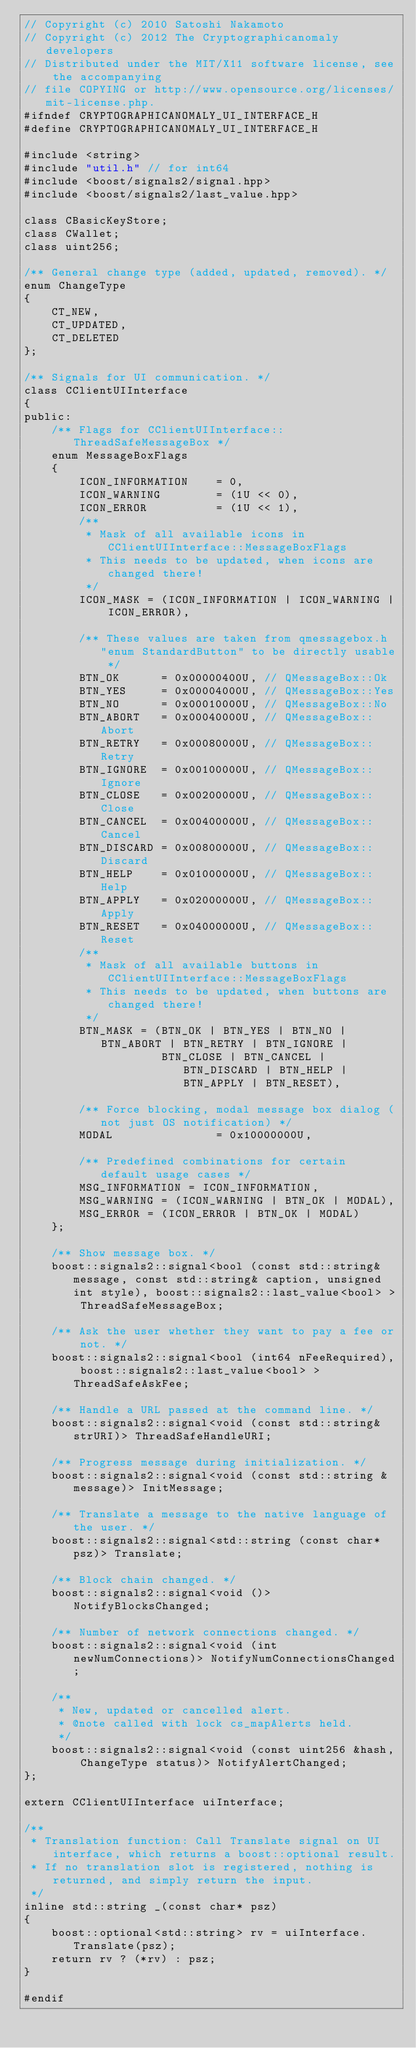Convert code to text. <code><loc_0><loc_0><loc_500><loc_500><_C_>// Copyright (c) 2010 Satoshi Nakamoto
// Copyright (c) 2012 The Cryptographicanomaly developers
// Distributed under the MIT/X11 software license, see the accompanying
// file COPYING or http://www.opensource.org/licenses/mit-license.php.
#ifndef CRYPTOGRAPHICANOMALY_UI_INTERFACE_H
#define CRYPTOGRAPHICANOMALY_UI_INTERFACE_H

#include <string>
#include "util.h" // for int64
#include <boost/signals2/signal.hpp>
#include <boost/signals2/last_value.hpp>

class CBasicKeyStore;
class CWallet;
class uint256;

/** General change type (added, updated, removed). */
enum ChangeType
{
    CT_NEW,
    CT_UPDATED,
    CT_DELETED
};

/** Signals for UI communication. */
class CClientUIInterface
{
public:
    /** Flags for CClientUIInterface::ThreadSafeMessageBox */
    enum MessageBoxFlags
    {
        ICON_INFORMATION    = 0,
        ICON_WARNING        = (1U << 0),
        ICON_ERROR          = (1U << 1),
        /**
         * Mask of all available icons in CClientUIInterface::MessageBoxFlags
         * This needs to be updated, when icons are changed there!
         */
        ICON_MASK = (ICON_INFORMATION | ICON_WARNING | ICON_ERROR),

        /** These values are taken from qmessagebox.h "enum StandardButton" to be directly usable */
        BTN_OK      = 0x00000400U, // QMessageBox::Ok
        BTN_YES     = 0x00004000U, // QMessageBox::Yes
        BTN_NO      = 0x00010000U, // QMessageBox::No
        BTN_ABORT   = 0x00040000U, // QMessageBox::Abort
        BTN_RETRY   = 0x00080000U, // QMessageBox::Retry
        BTN_IGNORE  = 0x00100000U, // QMessageBox::Ignore
        BTN_CLOSE   = 0x00200000U, // QMessageBox::Close
        BTN_CANCEL  = 0x00400000U, // QMessageBox::Cancel
        BTN_DISCARD = 0x00800000U, // QMessageBox::Discard
        BTN_HELP    = 0x01000000U, // QMessageBox::Help
        BTN_APPLY   = 0x02000000U, // QMessageBox::Apply
        BTN_RESET   = 0x04000000U, // QMessageBox::Reset
        /**
         * Mask of all available buttons in CClientUIInterface::MessageBoxFlags
         * This needs to be updated, when buttons are changed there!
         */
        BTN_MASK = (BTN_OK | BTN_YES | BTN_NO | BTN_ABORT | BTN_RETRY | BTN_IGNORE |
                    BTN_CLOSE | BTN_CANCEL | BTN_DISCARD | BTN_HELP | BTN_APPLY | BTN_RESET),

        /** Force blocking, modal message box dialog (not just OS notification) */
        MODAL               = 0x10000000U,

        /** Predefined combinations for certain default usage cases */
        MSG_INFORMATION = ICON_INFORMATION,
        MSG_WARNING = (ICON_WARNING | BTN_OK | MODAL),
        MSG_ERROR = (ICON_ERROR | BTN_OK | MODAL)
    };

    /** Show message box. */
    boost::signals2::signal<bool (const std::string& message, const std::string& caption, unsigned int style), boost::signals2::last_value<bool> > ThreadSafeMessageBox;

    /** Ask the user whether they want to pay a fee or not. */
    boost::signals2::signal<bool (int64 nFeeRequired), boost::signals2::last_value<bool> > ThreadSafeAskFee;

    /** Handle a URL passed at the command line. */
    boost::signals2::signal<void (const std::string& strURI)> ThreadSafeHandleURI;

    /** Progress message during initialization. */
    boost::signals2::signal<void (const std::string &message)> InitMessage;

    /** Translate a message to the native language of the user. */
    boost::signals2::signal<std::string (const char* psz)> Translate;

    /** Block chain changed. */
    boost::signals2::signal<void ()> NotifyBlocksChanged;

    /** Number of network connections changed. */
    boost::signals2::signal<void (int newNumConnections)> NotifyNumConnectionsChanged;

    /**
     * New, updated or cancelled alert.
     * @note called with lock cs_mapAlerts held.
     */
    boost::signals2::signal<void (const uint256 &hash, ChangeType status)> NotifyAlertChanged;
};

extern CClientUIInterface uiInterface;

/**
 * Translation function: Call Translate signal on UI interface, which returns a boost::optional result.
 * If no translation slot is registered, nothing is returned, and simply return the input.
 */
inline std::string _(const char* psz)
{
    boost::optional<std::string> rv = uiInterface.Translate(psz);
    return rv ? (*rv) : psz;
}

#endif
</code> 